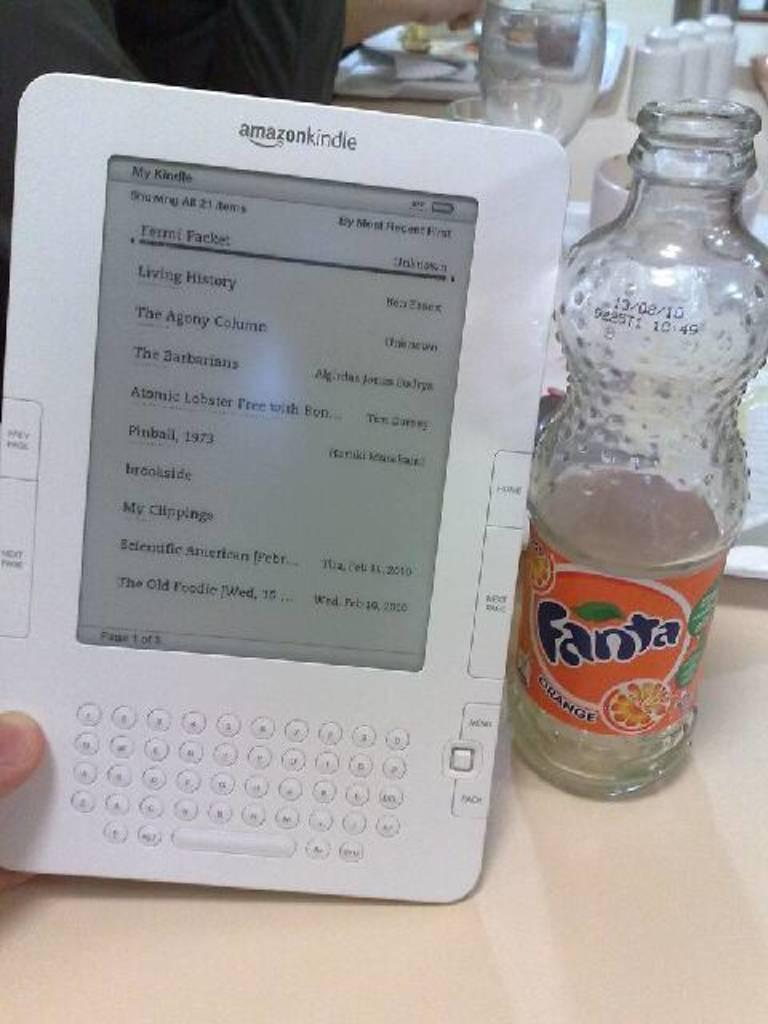<image>
Offer a succinct explanation of the picture presented. Person holding an Amazon Kindle next to an empty Fanta bottle. 